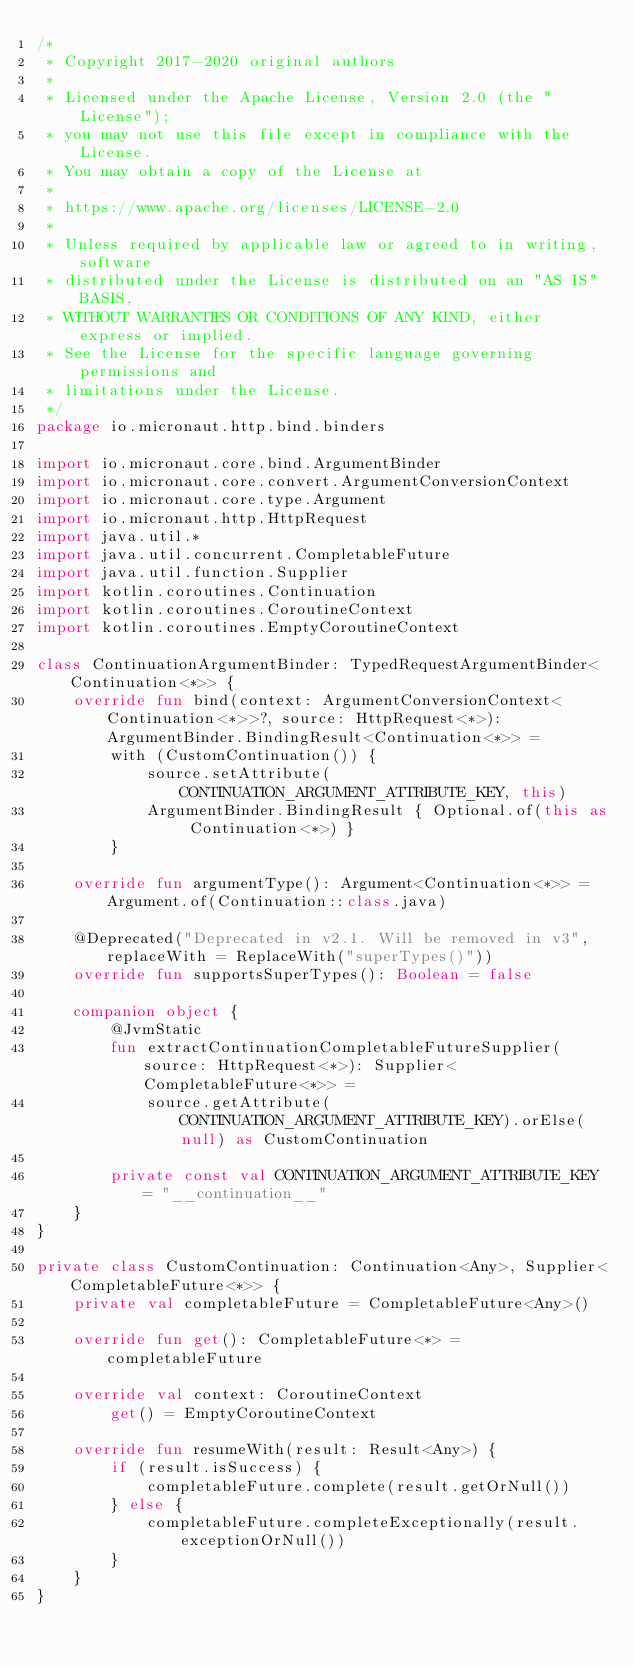Convert code to text. <code><loc_0><loc_0><loc_500><loc_500><_Kotlin_>/*
 * Copyright 2017-2020 original authors
 *
 * Licensed under the Apache License, Version 2.0 (the "License");
 * you may not use this file except in compliance with the License.
 * You may obtain a copy of the License at
 *
 * https://www.apache.org/licenses/LICENSE-2.0
 *
 * Unless required by applicable law or agreed to in writing, software
 * distributed under the License is distributed on an "AS IS" BASIS,
 * WITHOUT WARRANTIES OR CONDITIONS OF ANY KIND, either express or implied.
 * See the License for the specific language governing permissions and
 * limitations under the License.
 */
package io.micronaut.http.bind.binders

import io.micronaut.core.bind.ArgumentBinder
import io.micronaut.core.convert.ArgumentConversionContext
import io.micronaut.core.type.Argument
import io.micronaut.http.HttpRequest
import java.util.*
import java.util.concurrent.CompletableFuture
import java.util.function.Supplier
import kotlin.coroutines.Continuation
import kotlin.coroutines.CoroutineContext
import kotlin.coroutines.EmptyCoroutineContext

class ContinuationArgumentBinder: TypedRequestArgumentBinder<Continuation<*>> {
    override fun bind(context: ArgumentConversionContext<Continuation<*>>?, source: HttpRequest<*>): ArgumentBinder.BindingResult<Continuation<*>> =
        with (CustomContinuation()) {
            source.setAttribute(CONTINUATION_ARGUMENT_ATTRIBUTE_KEY, this)
            ArgumentBinder.BindingResult { Optional.of(this as Continuation<*>) }
        }

    override fun argumentType(): Argument<Continuation<*>> = Argument.of(Continuation::class.java)

    @Deprecated("Deprecated in v2.1. Will be removed in v3", replaceWith = ReplaceWith("superTypes()"))
    override fun supportsSuperTypes(): Boolean = false

    companion object {
        @JvmStatic
        fun extractContinuationCompletableFutureSupplier(source: HttpRequest<*>): Supplier<CompletableFuture<*>> =
            source.getAttribute(CONTINUATION_ARGUMENT_ATTRIBUTE_KEY).orElse(null) as CustomContinuation

        private const val CONTINUATION_ARGUMENT_ATTRIBUTE_KEY = "__continuation__"
    }
}

private class CustomContinuation: Continuation<Any>, Supplier<CompletableFuture<*>> {
    private val completableFuture = CompletableFuture<Any>()

    override fun get(): CompletableFuture<*> = completableFuture

    override val context: CoroutineContext
        get() = EmptyCoroutineContext

    override fun resumeWith(result: Result<Any>) {
        if (result.isSuccess) {
            completableFuture.complete(result.getOrNull())
        } else {
            completableFuture.completeExceptionally(result.exceptionOrNull())
        }
    }
}
</code> 